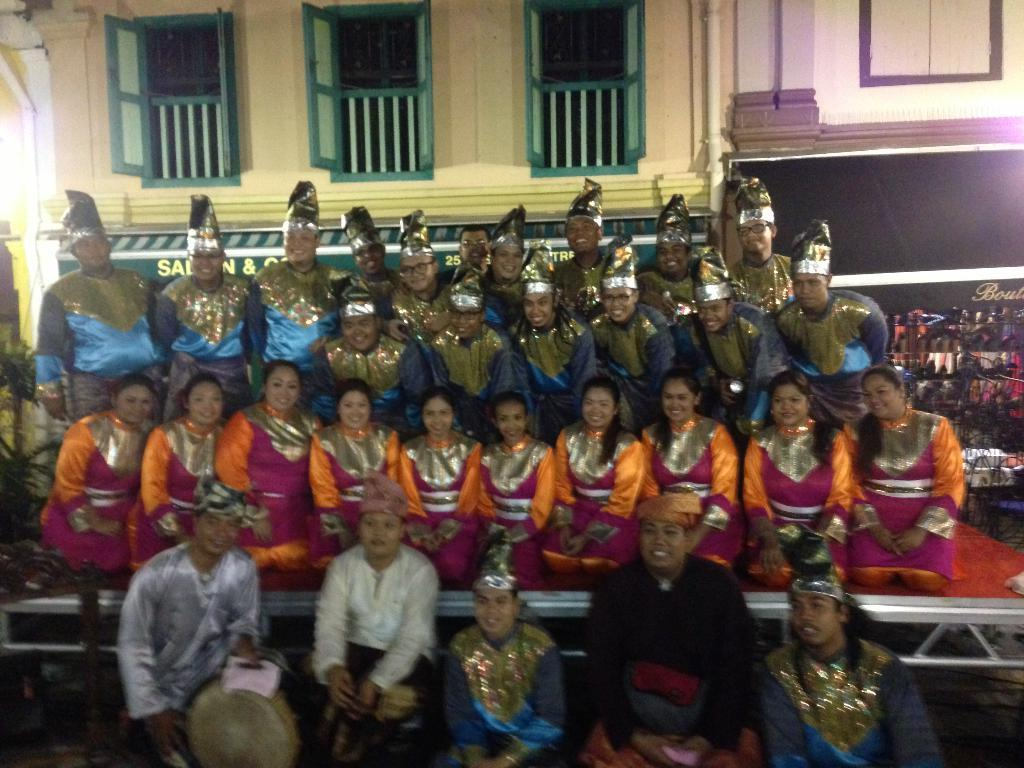What are the people in the image wearing? The people in the image are wearing costumes. What can be seen in the background of the image? There is a building in the background of the image. What feature of the building is visible? There are windows visible on the building. What is located on the right side of the image? There is a board on the right side of the image. How does the board control the memory of the people in the image? The board does not control the memory of the people in the image, as there is no indication of such a connection in the image. 